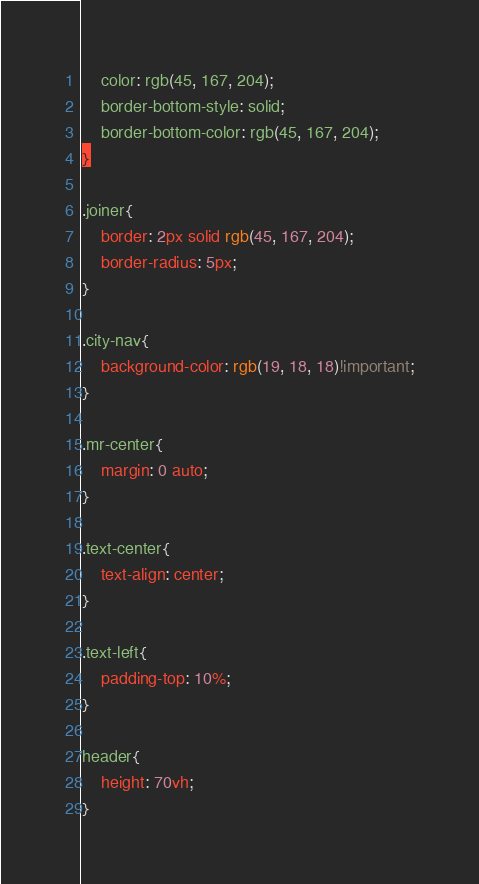<code> <loc_0><loc_0><loc_500><loc_500><_CSS_>    color: rgb(45, 167, 204);
    border-bottom-style: solid;
    border-bottom-color: rgb(45, 167, 204);
}

.joiner{
    border: 2px solid rgb(45, 167, 204);
    border-radius: 5px;
}

.city-nav{
    background-color: rgb(19, 18, 18)!important;
}

.mr-center{
    margin: 0 auto;
}

.text-center{
    text-align: center;
}

.text-left{
    padding-top: 10%;
}

header{
    height: 70vh;
}</code> 